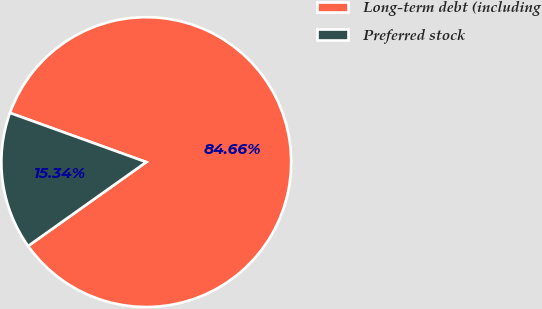Convert chart to OTSL. <chart><loc_0><loc_0><loc_500><loc_500><pie_chart><fcel>Long-term debt (including<fcel>Preferred stock<nl><fcel>84.66%<fcel>15.34%<nl></chart> 